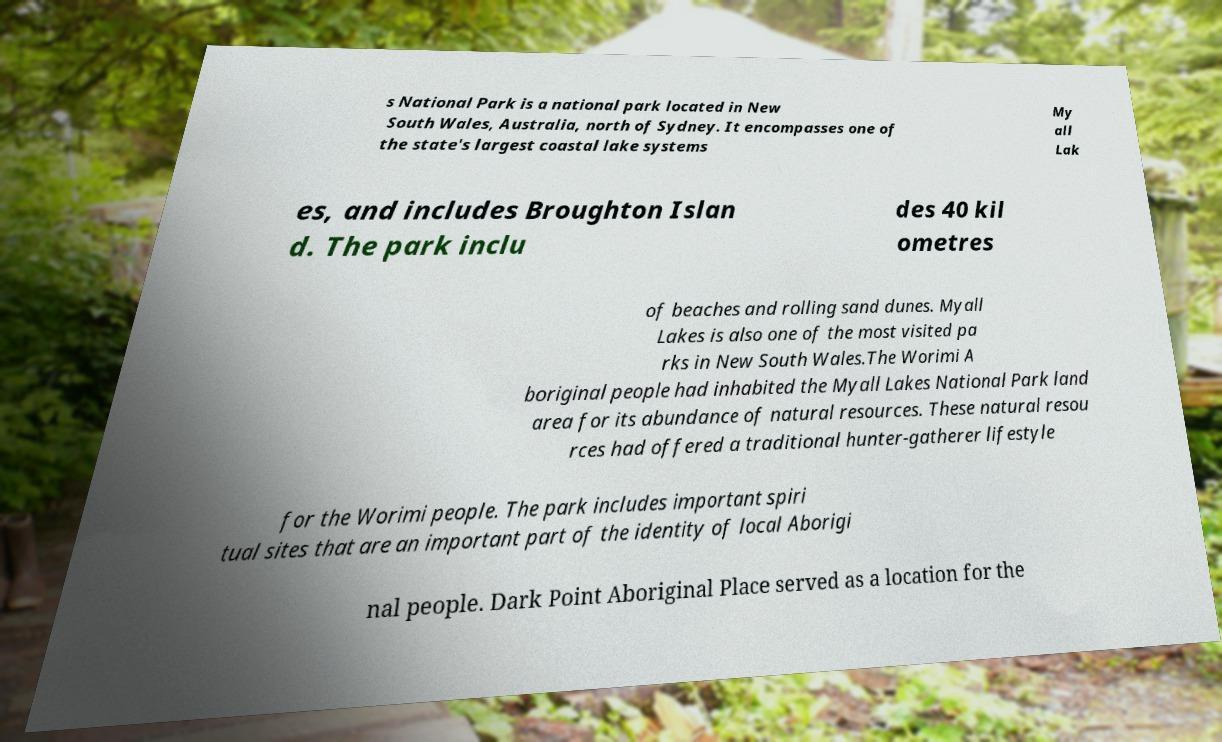Can you read and provide the text displayed in the image?This photo seems to have some interesting text. Can you extract and type it out for me? s National Park is a national park located in New South Wales, Australia, north of Sydney. It encompasses one of the state's largest coastal lake systems My all Lak es, and includes Broughton Islan d. The park inclu des 40 kil ometres of beaches and rolling sand dunes. Myall Lakes is also one of the most visited pa rks in New South Wales.The Worimi A boriginal people had inhabited the Myall Lakes National Park land area for its abundance of natural resources. These natural resou rces had offered a traditional hunter-gatherer lifestyle for the Worimi people. The park includes important spiri tual sites that are an important part of the identity of local Aborigi nal people. Dark Point Aboriginal Place served as a location for the 